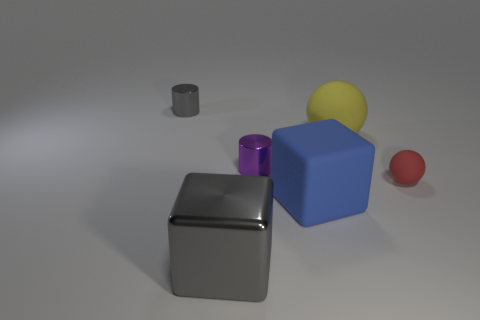What number of objects are metal objects that are right of the large gray object or shiny things that are in front of the blue rubber block?
Give a very brief answer. 2. There is a gray shiny thing behind the large thing behind the tiny red ball; what shape is it?
Provide a succinct answer. Cylinder. Is there a gray cube made of the same material as the gray cylinder?
Provide a succinct answer. Yes. The other metallic thing that is the same shape as the blue thing is what color?
Offer a terse response. Gray. Are there fewer tiny purple metallic cylinders that are on the right side of the big sphere than big gray objects right of the blue matte cube?
Provide a succinct answer. No. How many other objects are there of the same shape as the large yellow rubber thing?
Provide a succinct answer. 1. Are there fewer tiny purple things in front of the purple shiny object than shiny cylinders?
Keep it short and to the point. Yes. There is a large cube behind the big metallic object; what is it made of?
Your answer should be compact. Rubber. How many other objects are there of the same size as the yellow sphere?
Provide a succinct answer. 2. Is the number of yellow matte balls less than the number of yellow shiny cubes?
Your answer should be very brief. No. 